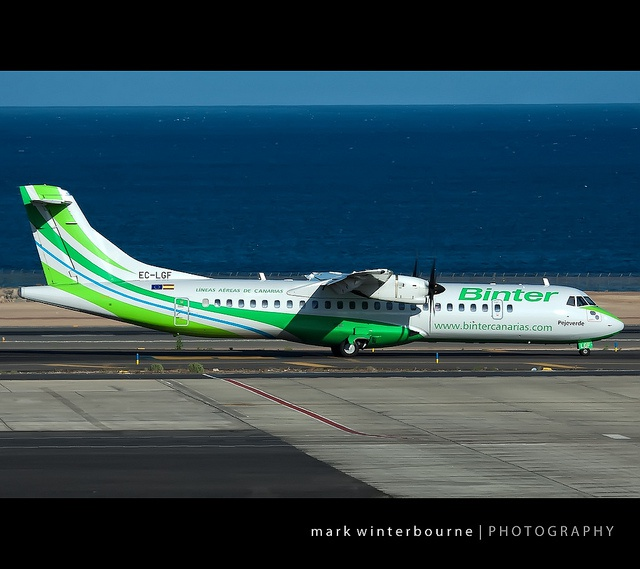Describe the objects in this image and their specific colors. I can see a airplane in black, lightgray, lightblue, and blue tones in this image. 